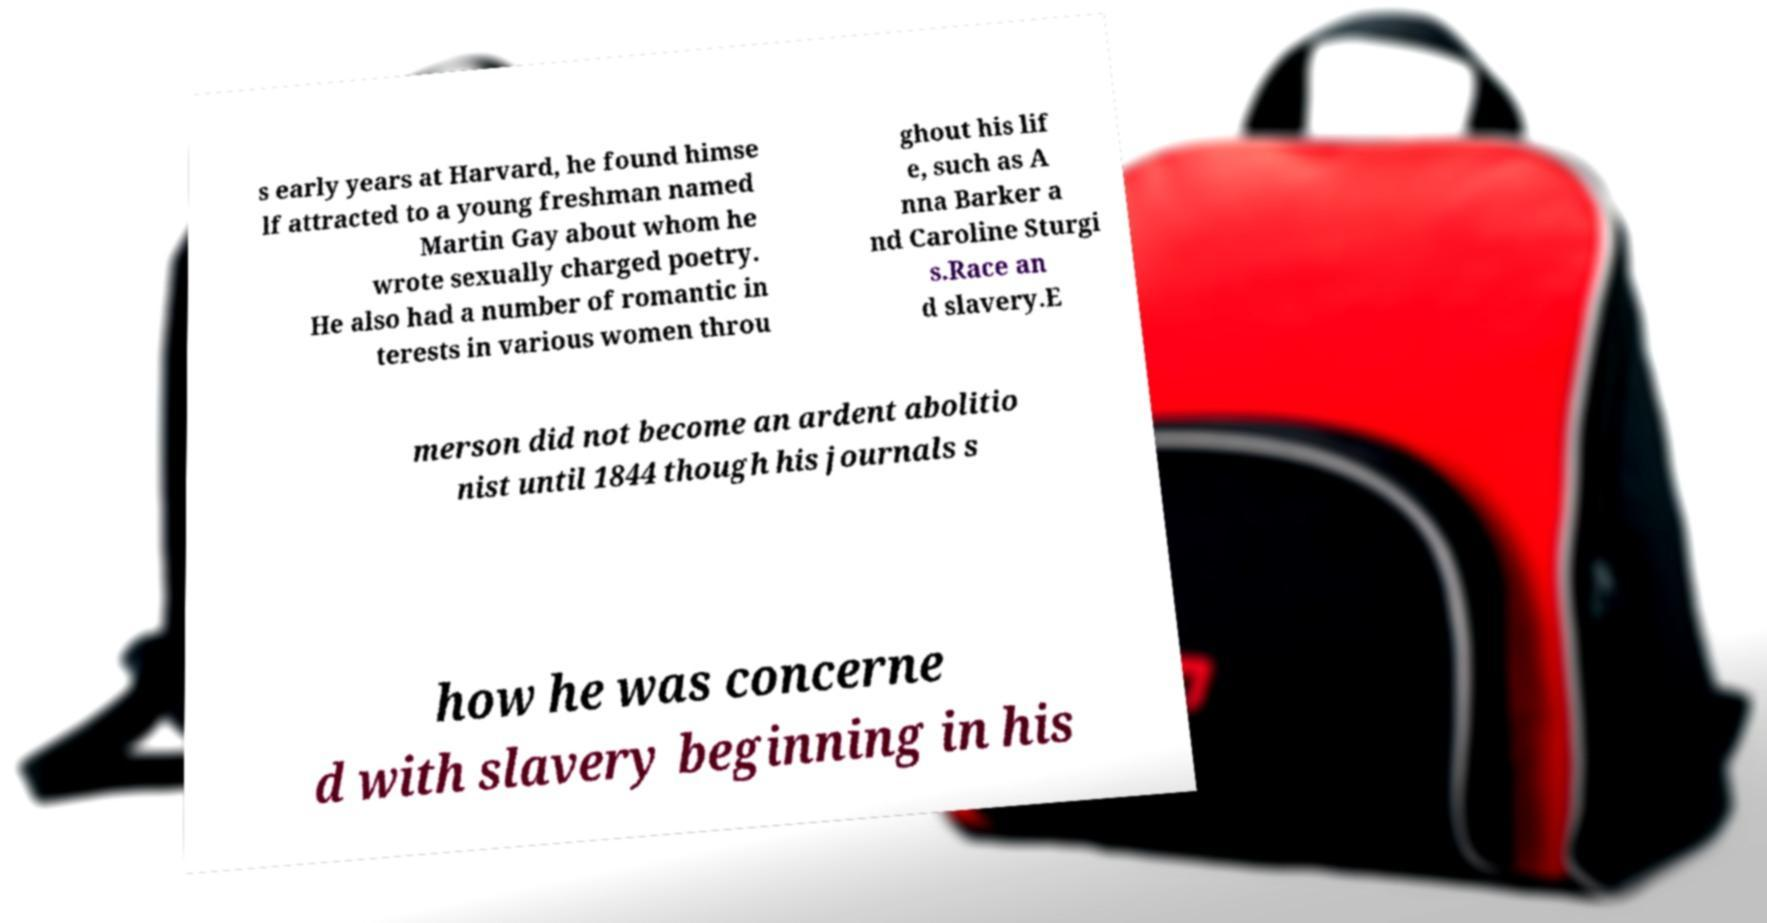For documentation purposes, I need the text within this image transcribed. Could you provide that? s early years at Harvard, he found himse lf attracted to a young freshman named Martin Gay about whom he wrote sexually charged poetry. He also had a number of romantic in terests in various women throu ghout his lif e, such as A nna Barker a nd Caroline Sturgi s.Race an d slavery.E merson did not become an ardent abolitio nist until 1844 though his journals s how he was concerne d with slavery beginning in his 